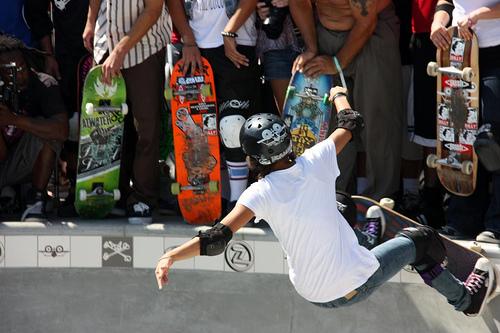What color is the middle skateboard?
Give a very brief answer. Orange. Is the kid skateboarding?
Short answer required. Yes. Do all the skateboards look the same?
Concise answer only. No. 